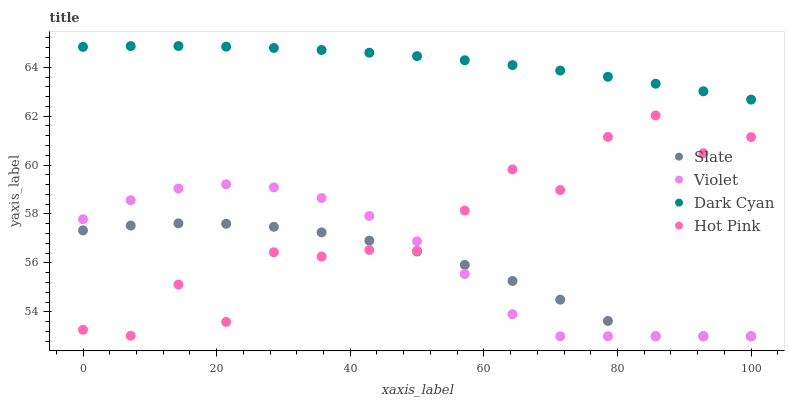Does Slate have the minimum area under the curve?
Answer yes or no. Yes. Does Dark Cyan have the maximum area under the curve?
Answer yes or no. Yes. Does Hot Pink have the minimum area under the curve?
Answer yes or no. No. Does Hot Pink have the maximum area under the curve?
Answer yes or no. No. Is Dark Cyan the smoothest?
Answer yes or no. Yes. Is Hot Pink the roughest?
Answer yes or no. Yes. Is Slate the smoothest?
Answer yes or no. No. Is Slate the roughest?
Answer yes or no. No. Does Slate have the lowest value?
Answer yes or no. Yes. Does Hot Pink have the lowest value?
Answer yes or no. No. Does Dark Cyan have the highest value?
Answer yes or no. Yes. Does Hot Pink have the highest value?
Answer yes or no. No. Is Violet less than Dark Cyan?
Answer yes or no. Yes. Is Dark Cyan greater than Hot Pink?
Answer yes or no. Yes. Does Slate intersect Hot Pink?
Answer yes or no. Yes. Is Slate less than Hot Pink?
Answer yes or no. No. Is Slate greater than Hot Pink?
Answer yes or no. No. Does Violet intersect Dark Cyan?
Answer yes or no. No. 